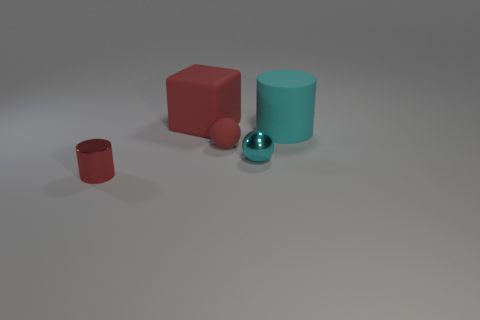Add 4 small red matte things. How many objects exist? 9 Subtract all cylinders. How many objects are left? 3 Subtract all small metal balls. Subtract all tiny cyan shiny objects. How many objects are left? 3 Add 2 big red objects. How many big red objects are left? 3 Add 2 large cubes. How many large cubes exist? 3 Subtract 0 blue cubes. How many objects are left? 5 